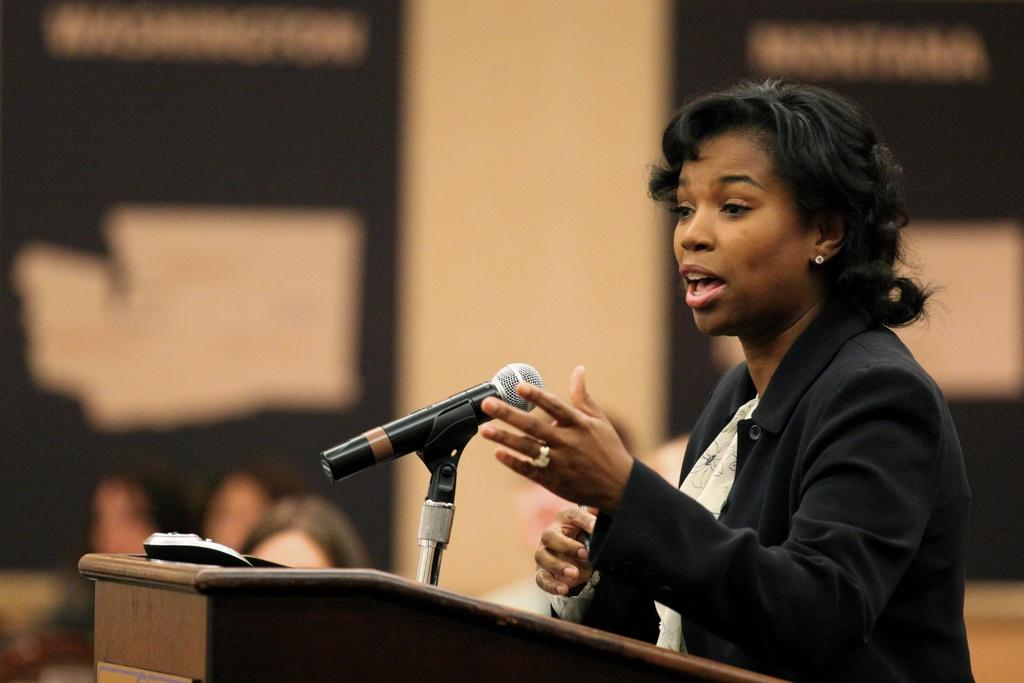What is the main subject of the image? There is a person standing in the image. What is the person wearing? The person is wearing a black blazer. What object is in front of the person? There is a podium in front of the person. What is on the podium? There is a microphone on the podium. How would you describe the background of the image? The background of the image is blurred. In which direction is the thread being pulled in the image? There is no thread present in the image. What is the addition to the person's attire in the image? The person is only wearing a black blazer, and there is no additional attire mentioned in the facts. 